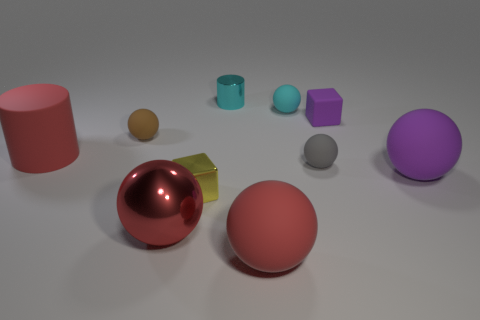There is a ball that is the same color as the tiny cylinder; what is its material?
Provide a short and direct response. Rubber. How many other things are the same color as the tiny metal cylinder?
Ensure brevity in your answer.  1. Are there fewer small purple cubes that are to the left of the cyan rubber sphere than large red matte objects that are right of the cyan cylinder?
Provide a short and direct response. Yes. How many objects are either red objects that are left of the tiny brown thing or red spheres?
Your answer should be compact. 3. Does the purple cube have the same size as the purple matte thing in front of the gray ball?
Provide a short and direct response. No. What size is the brown rubber thing that is the same shape as the gray thing?
Ensure brevity in your answer.  Small. How many purple things are in front of the sphere to the right of the block that is right of the small metal cylinder?
Keep it short and to the point. 0. How many balls are small yellow objects or tiny matte objects?
Your response must be concise. 3. What is the color of the small thing that is left of the block that is in front of the small gray object to the right of the tiny yellow metal cube?
Provide a succinct answer. Brown. How many other things are there of the same size as the brown ball?
Provide a succinct answer. 5. 